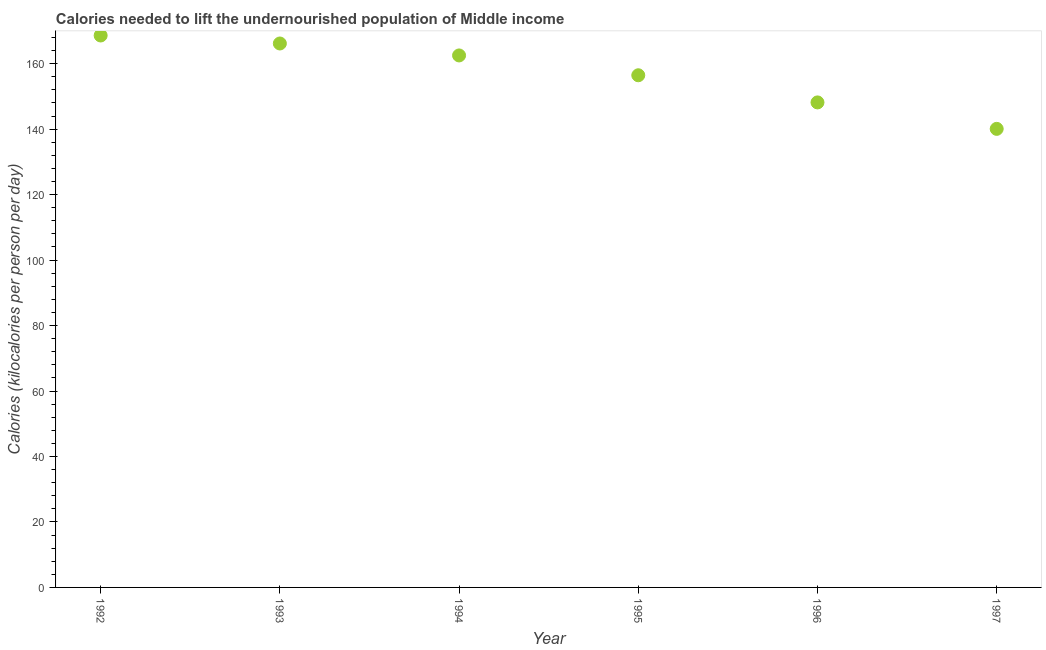What is the depth of food deficit in 1995?
Keep it short and to the point. 156.45. Across all years, what is the maximum depth of food deficit?
Provide a short and direct response. 168.6. Across all years, what is the minimum depth of food deficit?
Your answer should be very brief. 140.08. What is the sum of the depth of food deficit?
Your answer should be compact. 941.94. What is the difference between the depth of food deficit in 1992 and 1997?
Offer a terse response. 28.52. What is the average depth of food deficit per year?
Your answer should be compact. 156.99. What is the median depth of food deficit?
Your answer should be very brief. 159.48. In how many years, is the depth of food deficit greater than 108 kilocalories?
Make the answer very short. 6. What is the ratio of the depth of food deficit in 1992 to that in 1994?
Keep it short and to the point. 1.04. Is the depth of food deficit in 1992 less than that in 1994?
Your answer should be very brief. No. What is the difference between the highest and the second highest depth of food deficit?
Your answer should be compact. 2.44. What is the difference between the highest and the lowest depth of food deficit?
Provide a succinct answer. 28.52. Does the depth of food deficit monotonically increase over the years?
Your response must be concise. No. How many years are there in the graph?
Offer a very short reply. 6. Are the values on the major ticks of Y-axis written in scientific E-notation?
Ensure brevity in your answer.  No. Does the graph contain any zero values?
Your response must be concise. No. What is the title of the graph?
Keep it short and to the point. Calories needed to lift the undernourished population of Middle income. What is the label or title of the X-axis?
Provide a short and direct response. Year. What is the label or title of the Y-axis?
Your response must be concise. Calories (kilocalories per person per day). What is the Calories (kilocalories per person per day) in 1992?
Give a very brief answer. 168.6. What is the Calories (kilocalories per person per day) in 1993?
Offer a very short reply. 166.16. What is the Calories (kilocalories per person per day) in 1994?
Your answer should be very brief. 162.51. What is the Calories (kilocalories per person per day) in 1995?
Your answer should be very brief. 156.45. What is the Calories (kilocalories per person per day) in 1996?
Provide a succinct answer. 148.16. What is the Calories (kilocalories per person per day) in 1997?
Your answer should be compact. 140.08. What is the difference between the Calories (kilocalories per person per day) in 1992 and 1993?
Give a very brief answer. 2.44. What is the difference between the Calories (kilocalories per person per day) in 1992 and 1994?
Keep it short and to the point. 6.09. What is the difference between the Calories (kilocalories per person per day) in 1992 and 1995?
Make the answer very short. 12.15. What is the difference between the Calories (kilocalories per person per day) in 1992 and 1996?
Provide a short and direct response. 20.44. What is the difference between the Calories (kilocalories per person per day) in 1992 and 1997?
Provide a short and direct response. 28.52. What is the difference between the Calories (kilocalories per person per day) in 1993 and 1994?
Give a very brief answer. 3.65. What is the difference between the Calories (kilocalories per person per day) in 1993 and 1995?
Your answer should be very brief. 9.71. What is the difference between the Calories (kilocalories per person per day) in 1993 and 1996?
Offer a very short reply. 18. What is the difference between the Calories (kilocalories per person per day) in 1993 and 1997?
Make the answer very short. 26.08. What is the difference between the Calories (kilocalories per person per day) in 1994 and 1995?
Your answer should be very brief. 6.06. What is the difference between the Calories (kilocalories per person per day) in 1994 and 1996?
Your answer should be very brief. 14.35. What is the difference between the Calories (kilocalories per person per day) in 1994 and 1997?
Ensure brevity in your answer.  22.43. What is the difference between the Calories (kilocalories per person per day) in 1995 and 1996?
Your answer should be very brief. 8.29. What is the difference between the Calories (kilocalories per person per day) in 1995 and 1997?
Your answer should be compact. 16.37. What is the difference between the Calories (kilocalories per person per day) in 1996 and 1997?
Provide a succinct answer. 8.08. What is the ratio of the Calories (kilocalories per person per day) in 1992 to that in 1993?
Ensure brevity in your answer.  1.01. What is the ratio of the Calories (kilocalories per person per day) in 1992 to that in 1995?
Give a very brief answer. 1.08. What is the ratio of the Calories (kilocalories per person per day) in 1992 to that in 1996?
Provide a succinct answer. 1.14. What is the ratio of the Calories (kilocalories per person per day) in 1992 to that in 1997?
Give a very brief answer. 1.2. What is the ratio of the Calories (kilocalories per person per day) in 1993 to that in 1995?
Provide a succinct answer. 1.06. What is the ratio of the Calories (kilocalories per person per day) in 1993 to that in 1996?
Make the answer very short. 1.12. What is the ratio of the Calories (kilocalories per person per day) in 1993 to that in 1997?
Give a very brief answer. 1.19. What is the ratio of the Calories (kilocalories per person per day) in 1994 to that in 1995?
Ensure brevity in your answer.  1.04. What is the ratio of the Calories (kilocalories per person per day) in 1994 to that in 1996?
Give a very brief answer. 1.1. What is the ratio of the Calories (kilocalories per person per day) in 1994 to that in 1997?
Your answer should be compact. 1.16. What is the ratio of the Calories (kilocalories per person per day) in 1995 to that in 1996?
Ensure brevity in your answer.  1.06. What is the ratio of the Calories (kilocalories per person per day) in 1995 to that in 1997?
Keep it short and to the point. 1.12. What is the ratio of the Calories (kilocalories per person per day) in 1996 to that in 1997?
Offer a terse response. 1.06. 